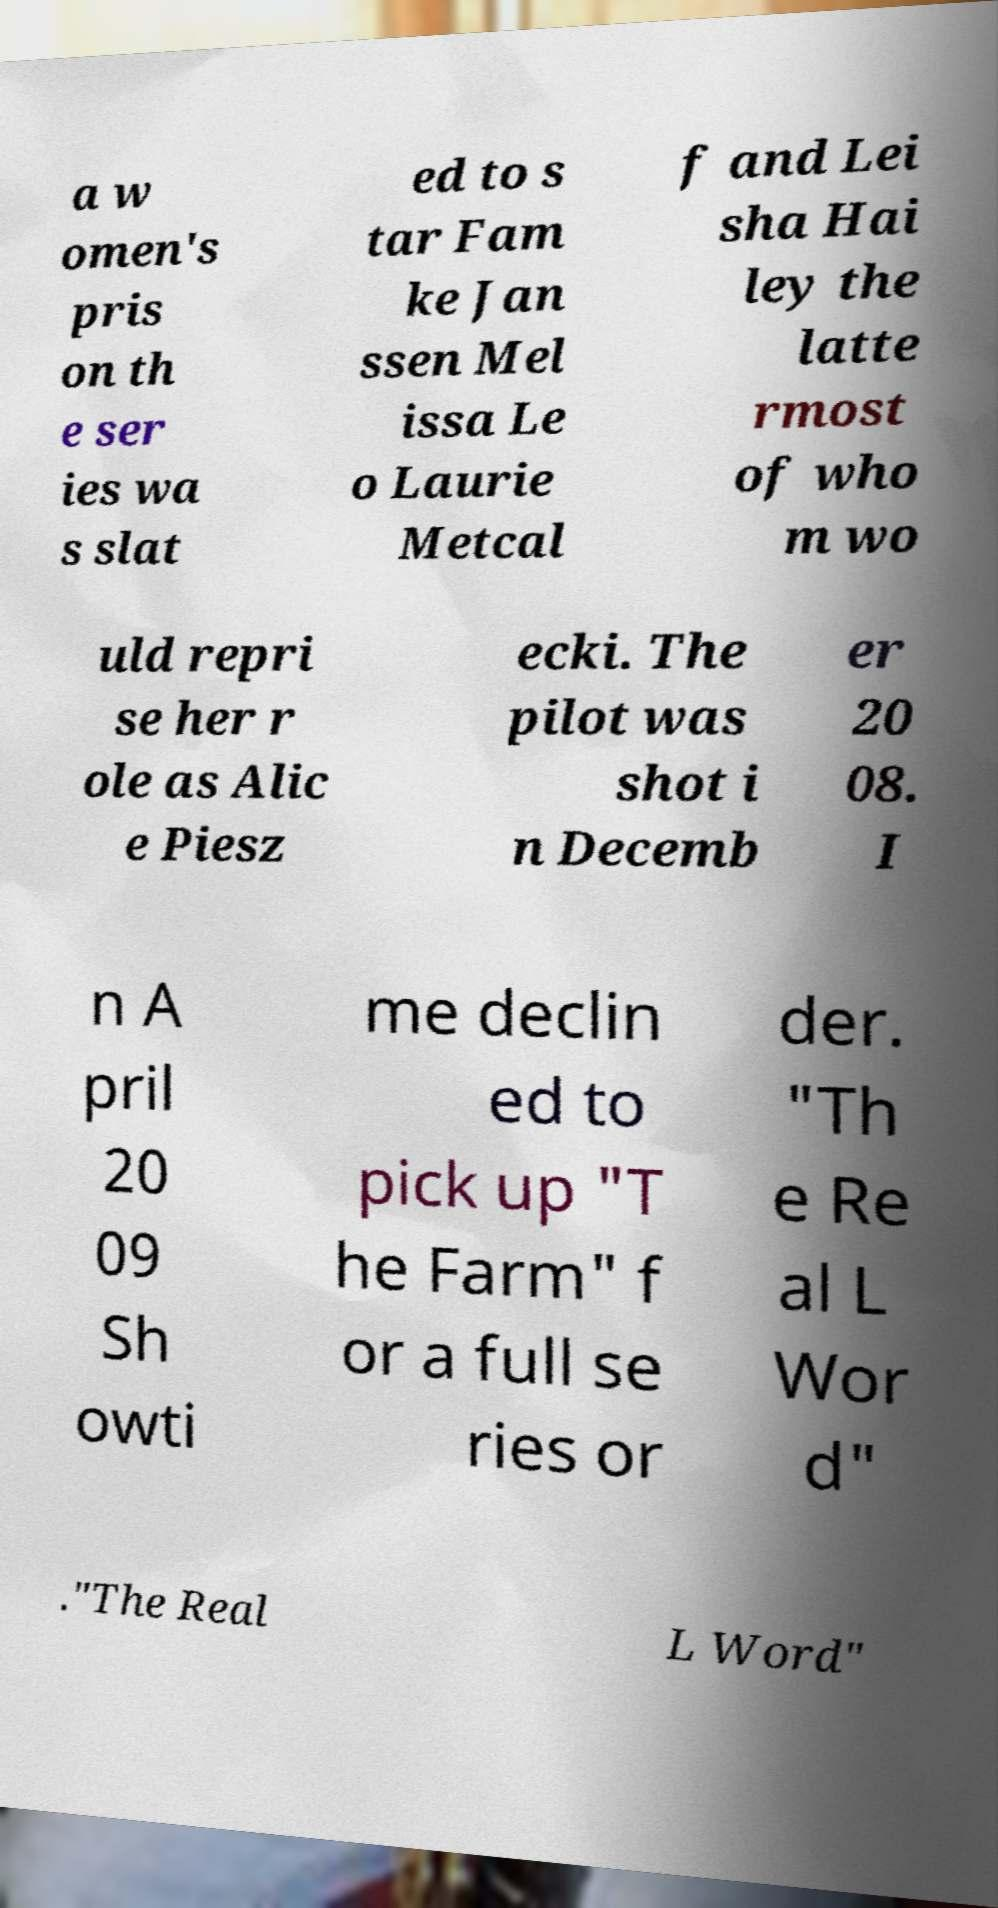Can you accurately transcribe the text from the provided image for me? a w omen's pris on th e ser ies wa s slat ed to s tar Fam ke Jan ssen Mel issa Le o Laurie Metcal f and Lei sha Hai ley the latte rmost of who m wo uld repri se her r ole as Alic e Piesz ecki. The pilot was shot i n Decemb er 20 08. I n A pril 20 09 Sh owti me declin ed to pick up "T he Farm" f or a full se ries or der. "Th e Re al L Wor d" ."The Real L Word" 